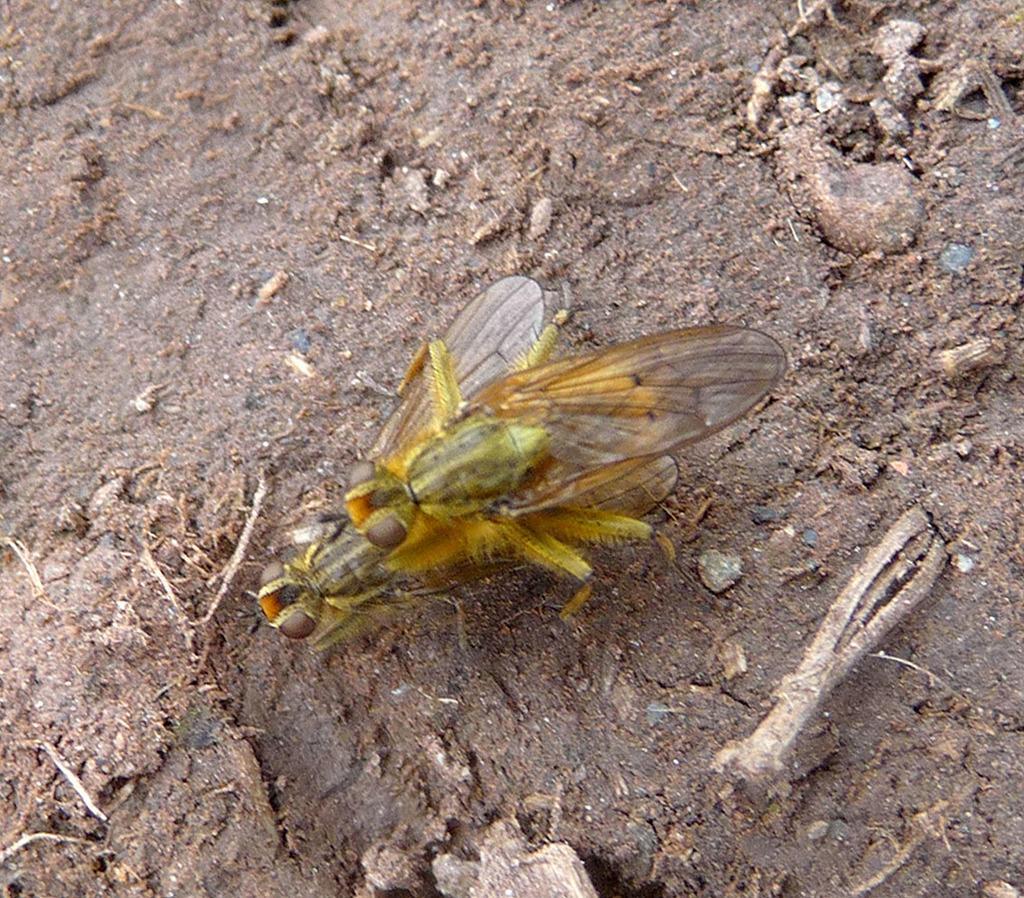Describe this image in one or two sentences. In the center of the image, we can see aliens on the ground and there are some twigs. 